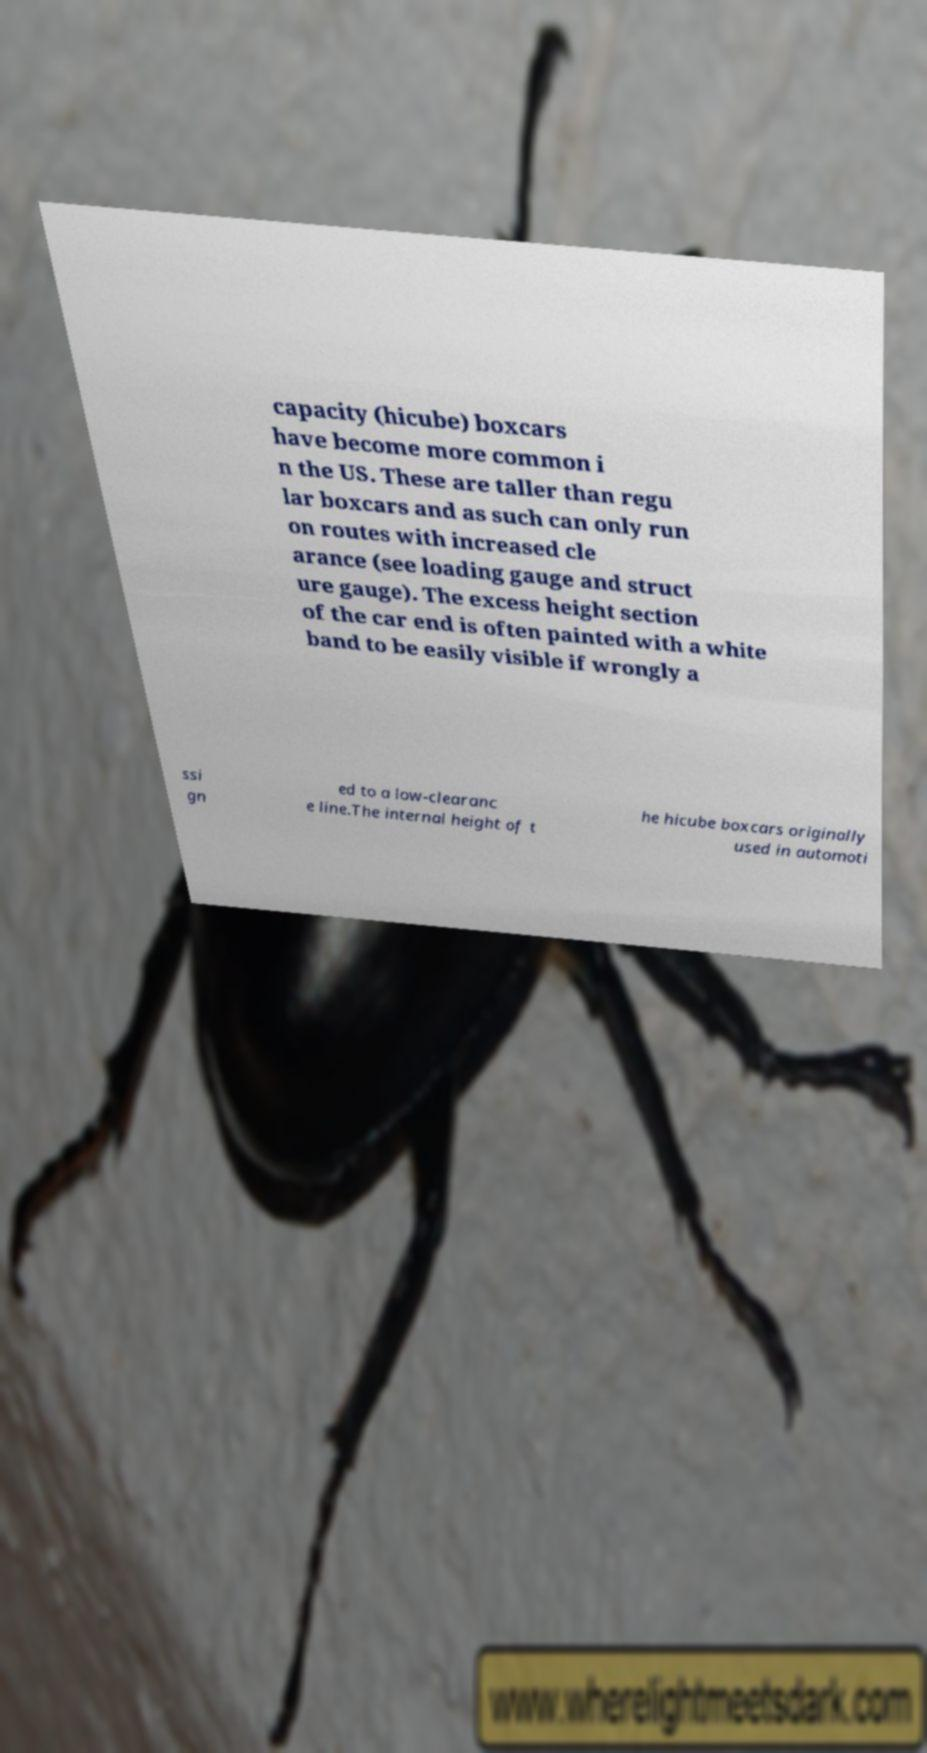There's text embedded in this image that I need extracted. Can you transcribe it verbatim? capacity (hicube) boxcars have become more common i n the US. These are taller than regu lar boxcars and as such can only run on routes with increased cle arance (see loading gauge and struct ure gauge). The excess height section of the car end is often painted with a white band to be easily visible if wrongly a ssi gn ed to a low-clearanc e line.The internal height of t he hicube boxcars originally used in automoti 